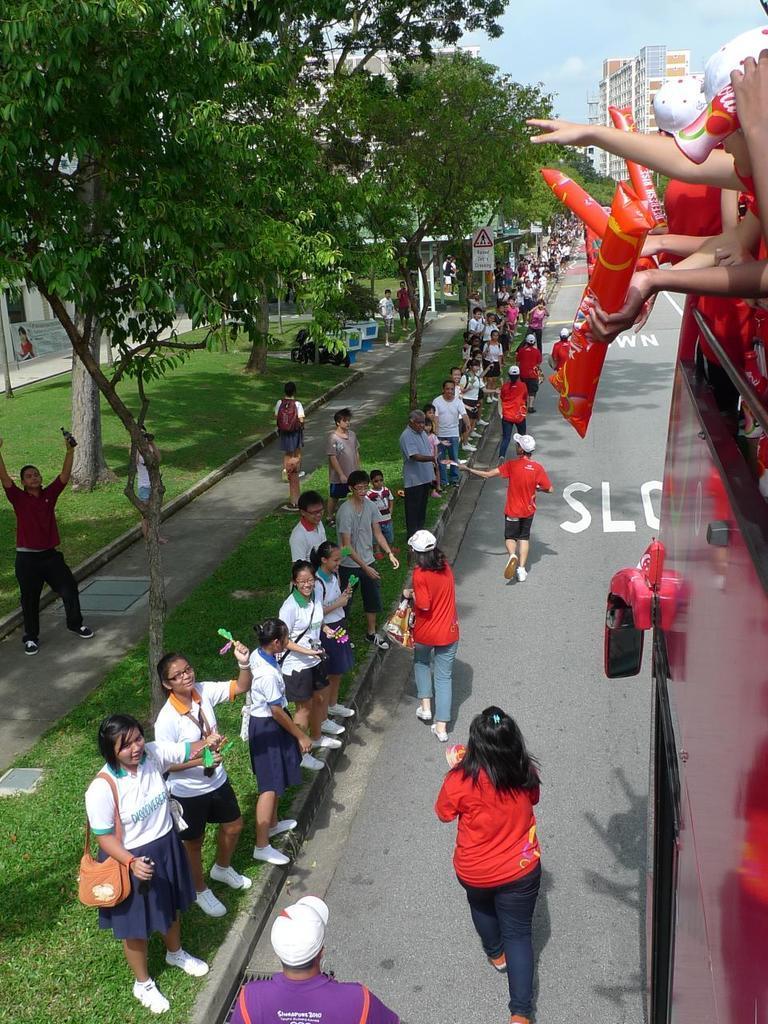Describe this image in one or two sentences. In this image there are few people are standing on the path and few are walking on the road, beside them there is a vehicle and few people are standing. On the left side of the image there are trees, beneath the trees there are few people and few objects are placed on the surface of the grass. In the background there are buildings and the sky. 